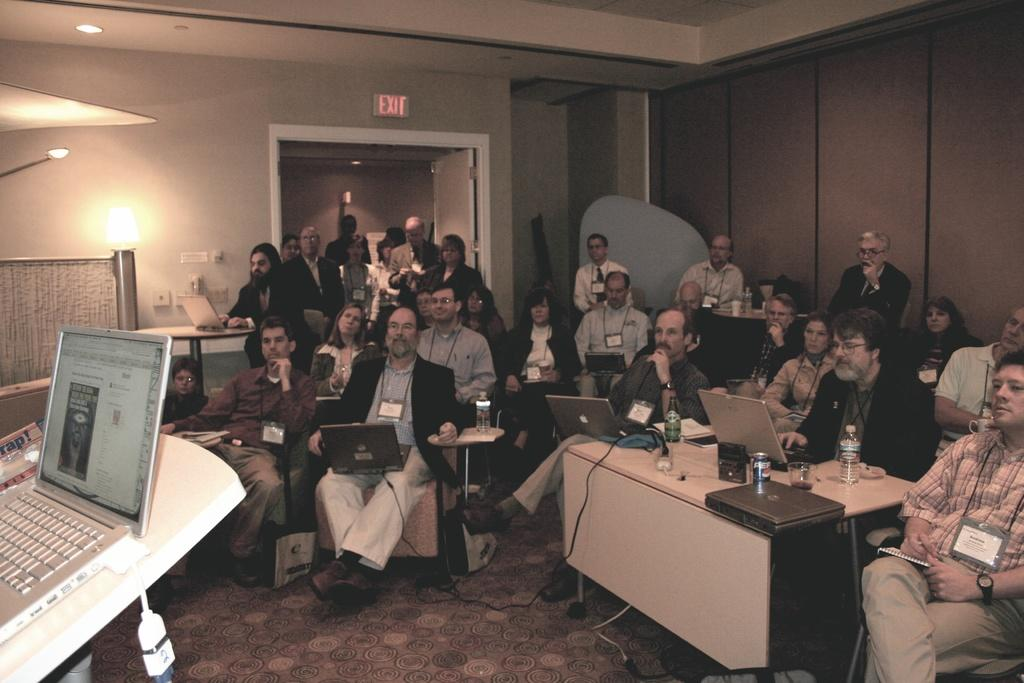What are the people in the image doing? There are people sitting on chairs and standing in the image. What objects can be seen on the table in the image? There are laptops on a table in the image. What type of salt is being used by the people in the image? There is no salt present in the image. Can you tell me how many guitars are being played by the people in the image? There are no guitars present in the image. 